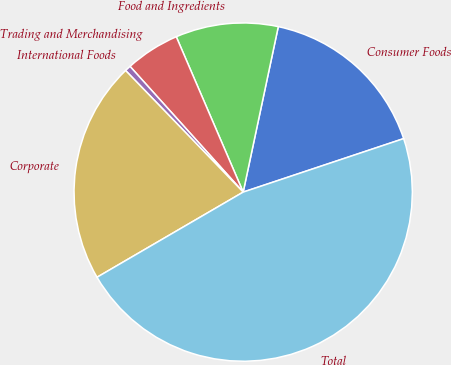<chart> <loc_0><loc_0><loc_500><loc_500><pie_chart><fcel>Consumer Foods<fcel>Food and Ingredients<fcel>Trading and Merchandising<fcel>International Foods<fcel>Corporate<fcel>Total<nl><fcel>16.55%<fcel>9.8%<fcel>5.19%<fcel>0.57%<fcel>21.16%<fcel>46.72%<nl></chart> 